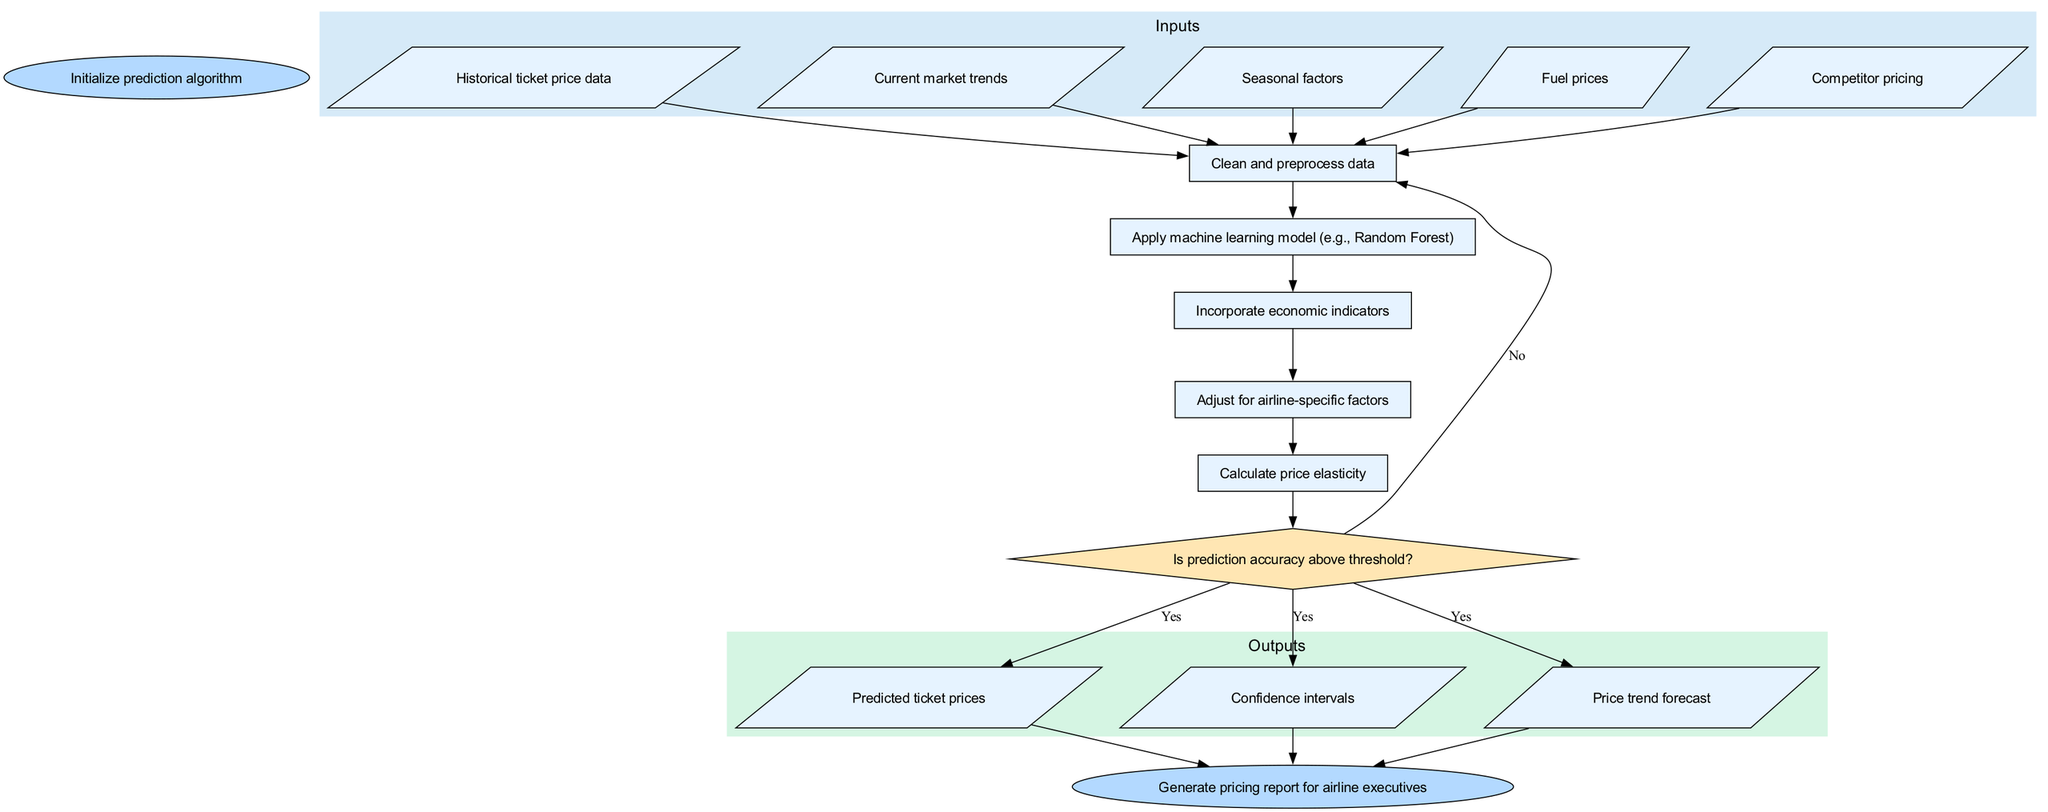What is the first step in the algorithm? The diagram indicates that the first step in the algorithm is to "Initialize prediction algorithm." This is the first node in the flow, signaling the beginning of the process.
Answer: Initialize prediction algorithm How many inputs are there in the algorithm? The diagram lists five inputs: historical ticket price data, current market trends, seasonal factors, fuel prices, and competitor pricing. The total number of input nodes confirms this count.
Answer: Five What happens if the prediction accuracy is below the threshold? According to the diagram, if the prediction accuracy is below the threshold, the flow loops back to the first process, which is "Clean and preprocess data." This indicates that the algorithm initiates the process again to improve accuracy.
Answer: Loop back to the first process Which process follows data cleaning? The process that follows data cleaning (the first process) is "Apply machine learning model (e.g., Random Forest)." The flows from the data cleaning process point directly to this second process.
Answer: Apply machine learning model What are the outputs of the algorithm? There are three outputs from the algorithm: predicted ticket prices, confidence intervals, and price trend forecast. Each is represented as a distinct output node in the flowchart.
Answer: Predicted ticket prices, confidence intervals, price trend forecast What type of node represents the decision point in the algorithm? The decision point in the algorithm is represented by a diamond-shaped node. This shape indicates where a choice must be made based on the condition of prediction accuracy.
Answer: Diamond How many final output nodes are there? The diagram clearly shows three final output nodes, each corresponding to the outputs of the algorithm. Therefore, the total count of output nodes confirms this number.
Answer: Three What decision leads to generating the pricing report? The decision to generate the pricing report for airline executives is dependent on whether the prediction accuracy is above the threshold. If the answer is yes, the flow leads directly to the report generation.
Answer: Yes What is the last step of the algorithm? The last step based on the flowchart is "Generate pricing report for airline executives." This indicates that once all previous processes and outputs are completed, the final report is produced.
Answer: Generate pricing report for airline executives 